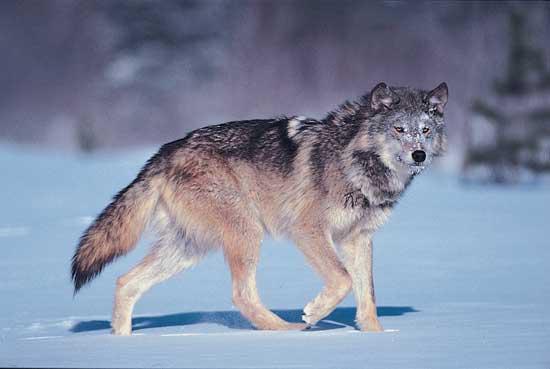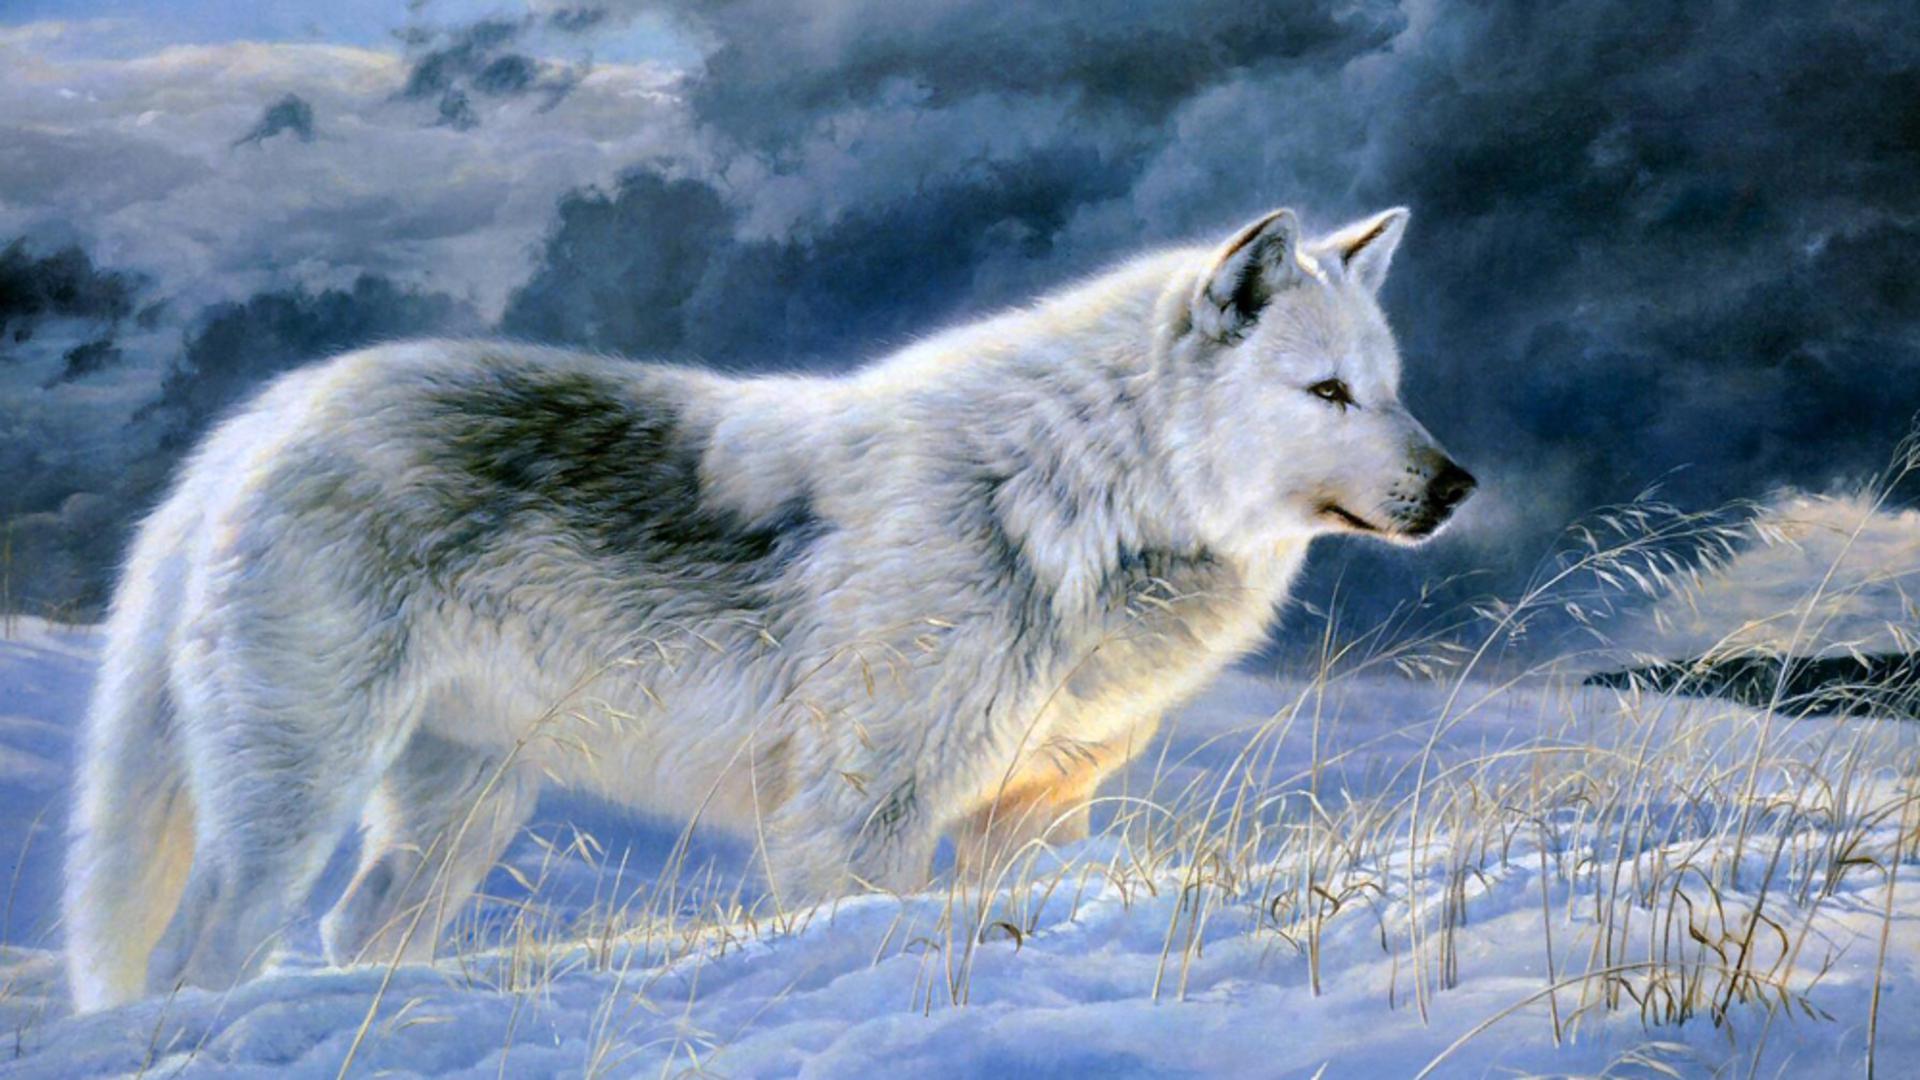The first image is the image on the left, the second image is the image on the right. Evaluate the accuracy of this statement regarding the images: "There is a wolf sitting in the snow". Is it true? Answer yes or no. No. 